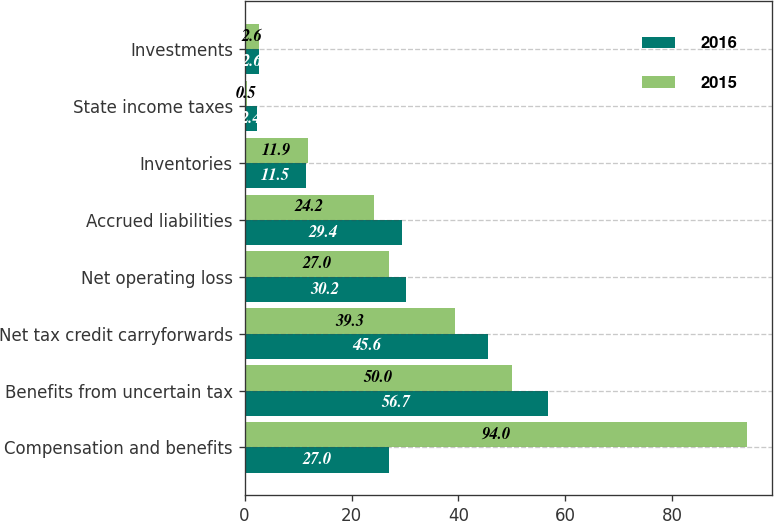Convert chart to OTSL. <chart><loc_0><loc_0><loc_500><loc_500><stacked_bar_chart><ecel><fcel>Compensation and benefits<fcel>Benefits from uncertain tax<fcel>Net tax credit carryforwards<fcel>Net operating loss<fcel>Accrued liabilities<fcel>Inventories<fcel>State income taxes<fcel>Investments<nl><fcel>2016<fcel>27<fcel>56.7<fcel>45.6<fcel>30.2<fcel>29.4<fcel>11.5<fcel>2.4<fcel>2.6<nl><fcel>2015<fcel>94<fcel>50<fcel>39.3<fcel>27<fcel>24.2<fcel>11.9<fcel>0.5<fcel>2.6<nl></chart> 